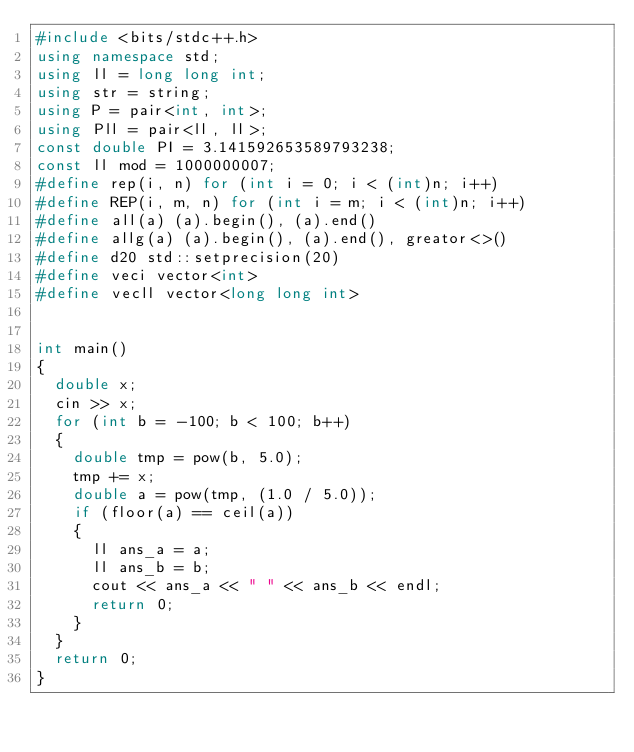<code> <loc_0><loc_0><loc_500><loc_500><_C++_>#include <bits/stdc++.h>
using namespace std;
using ll = long long int;
using str = string;
using P = pair<int, int>;
using Pll = pair<ll, ll>;
const double PI = 3.141592653589793238;
const ll mod = 1000000007;
#define rep(i, n) for (int i = 0; i < (int)n; i++)
#define REP(i, m, n) for (int i = m; i < (int)n; i++)
#define all(a) (a).begin(), (a).end()
#define allg(a) (a).begin(), (a).end(), greator<>()
#define d20 std::setprecision(20)
#define veci vector<int>
#define vecll vector<long long int>


int main()
{
	double x;
	cin >> x;
	for (int b = -100; b < 100; b++)
	{
		double tmp = pow(b, 5.0);
		tmp += x;
		double a = pow(tmp, (1.0 / 5.0));
		if (floor(a) == ceil(a))
		{
			ll ans_a = a;
			ll ans_b = b;
			cout << ans_a << " " << ans_b << endl;
			return 0;
		}
	}
	return 0;
}</code> 